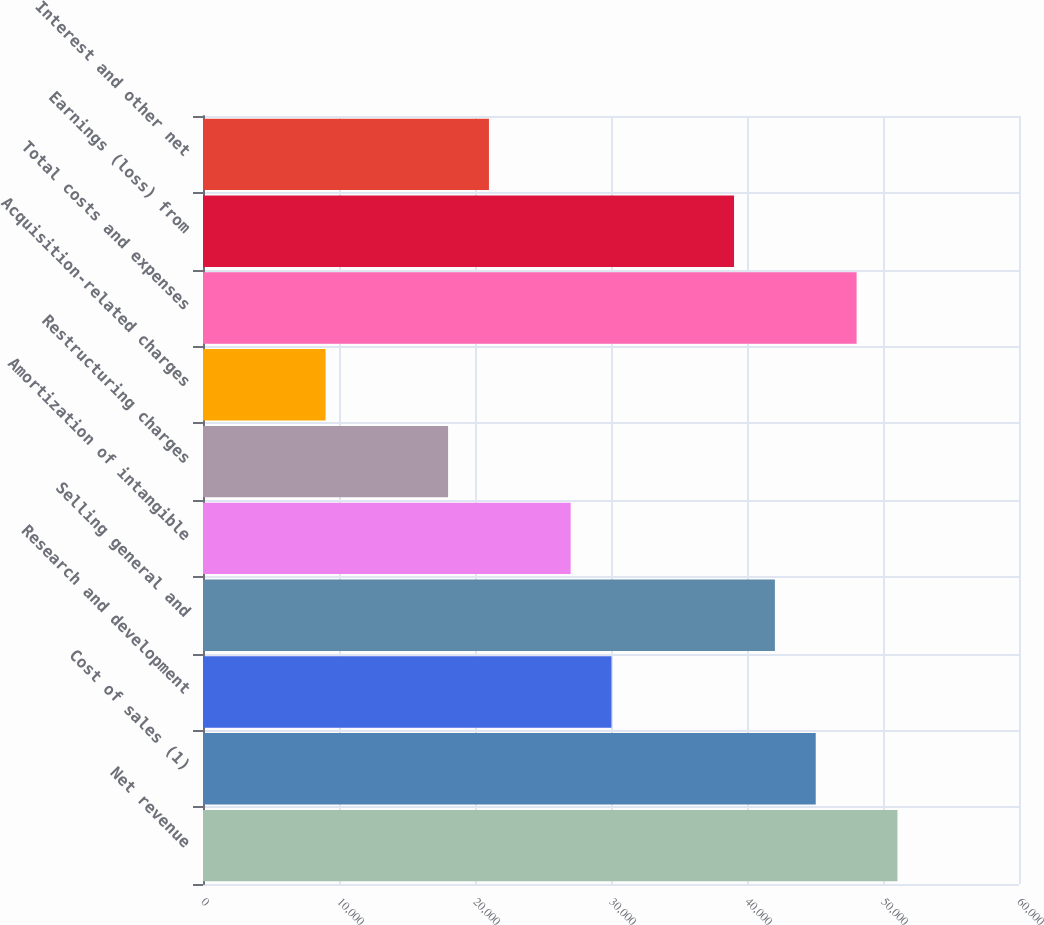<chart> <loc_0><loc_0><loc_500><loc_500><bar_chart><fcel>Net revenue<fcel>Cost of sales (1)<fcel>Research and development<fcel>Selling general and<fcel>Amortization of intangible<fcel>Restructuring charges<fcel>Acquisition-related charges<fcel>Total costs and expenses<fcel>Earnings (loss) from<fcel>Interest and other net<nl><fcel>51061.2<fcel>45054<fcel>30036<fcel>42050.4<fcel>27032.4<fcel>18021.7<fcel>9010.89<fcel>48057.6<fcel>39046.8<fcel>21025.2<nl></chart> 